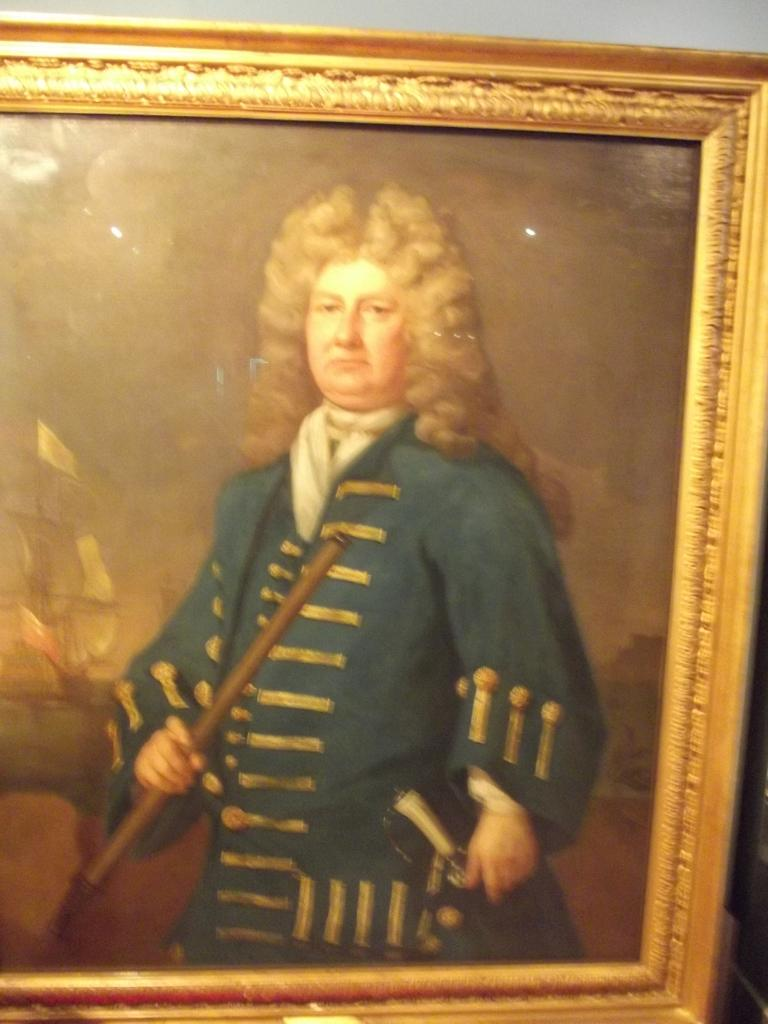What is the main subject in the foreground of the image? There is a person's photo frame in the foreground of the image. What can be seen in the background of the image? There is a wall in the image. Can you describe the setting of the image? The image may have been taken in a room, as there is a wall visible in the background. How many apples are on the road in the image? There are no apples or roads present in the image; it features a person's photo frame and a wall. What type of cows can be seen grazing in the background of the image? There are no cows present in the image; it features a person's photo frame and a wall. 